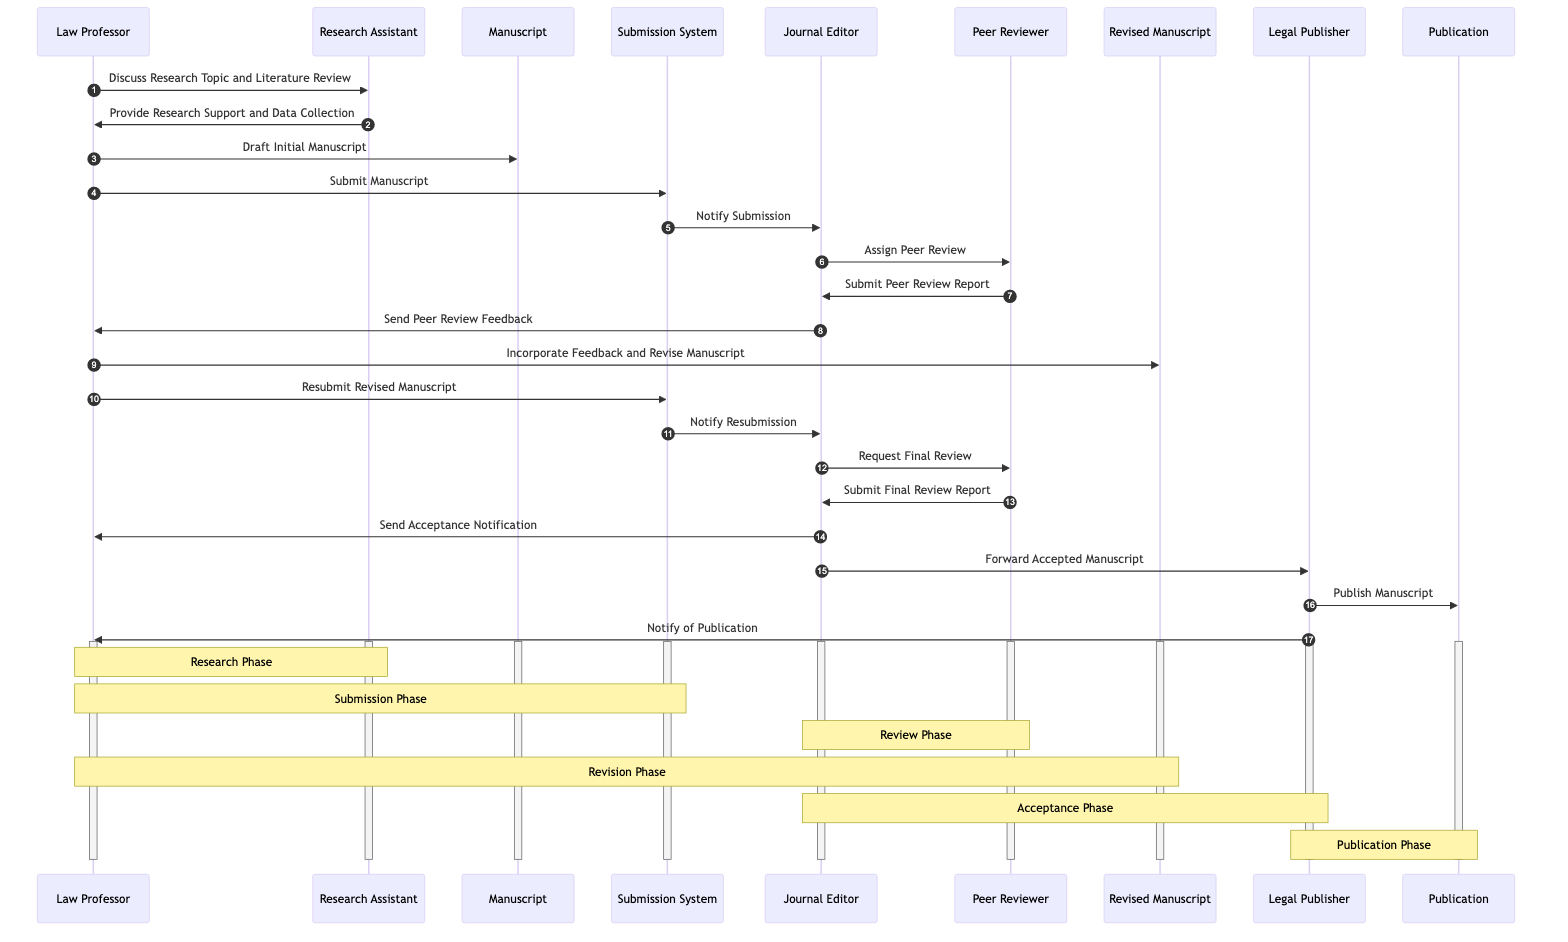What are the main actors in the diagram? The diagram includes several actors: the Law Professor, Research Assistant, Journal Editor, Peer Reviewer, and Legal Publisher. These actors are engaged in various stages of the legal publishing process as depicted in the diagram.
Answer: Law Professor, Research Assistant, Journal Editor, Peer Reviewer, Legal Publisher How many messages are exchanged in the process? Counting all the arrows/messages from one actor to another in the diagram reveals a total of 15 messages. This includes initial submissions, feedbacks, and notifications throughout the process.
Answer: 15 What phase follows the Peer Review Phase in the diagram? After the Peer Review Phase, the process moves to the Acceptance Phase. This is denoted by the Journal Editor sending the Acceptance Notification to the Law Professor.
Answer: Acceptance Phase Who sends the Acceptance Notification? The Journal Editor is responsible for sending the Acceptance Notification to the Law Professor after the peer review process is completed.
Answer: Journal Editor Which actor provides research support and data collection? The Research Assistant is the actor designated to provide research support and data collection to the Law Professor. This task occurs after the initial discussion about the research topic.
Answer: Research Assistant How many times does the Law Professor interact with the Submission System? The Law Professor interacts with the Submission System twice: once for submitting the manuscript and a second time for resubmitting the revised manuscript.
Answer: 2 What document is forwarded to the Legal Publisher? After acceptance, the Journal Editor forwards the Accepted Manuscript to the Legal Publisher, indicating that it is ready for publication.
Answer: Accepted Manuscript What is the final action completed in the sequence? The final action in the sequence is the Legal Publisher publishing the manuscript, which signifies the end of the legal publishing process depicted in the diagram.
Answer: Publish Manuscript During which phase does the Law Professor incorporate feedback? This action occurs during the Revision Phase, where the Law Professor incorporates feedback from the peer review process and revises the manuscript accordingly.
Answer: Revision Phase 